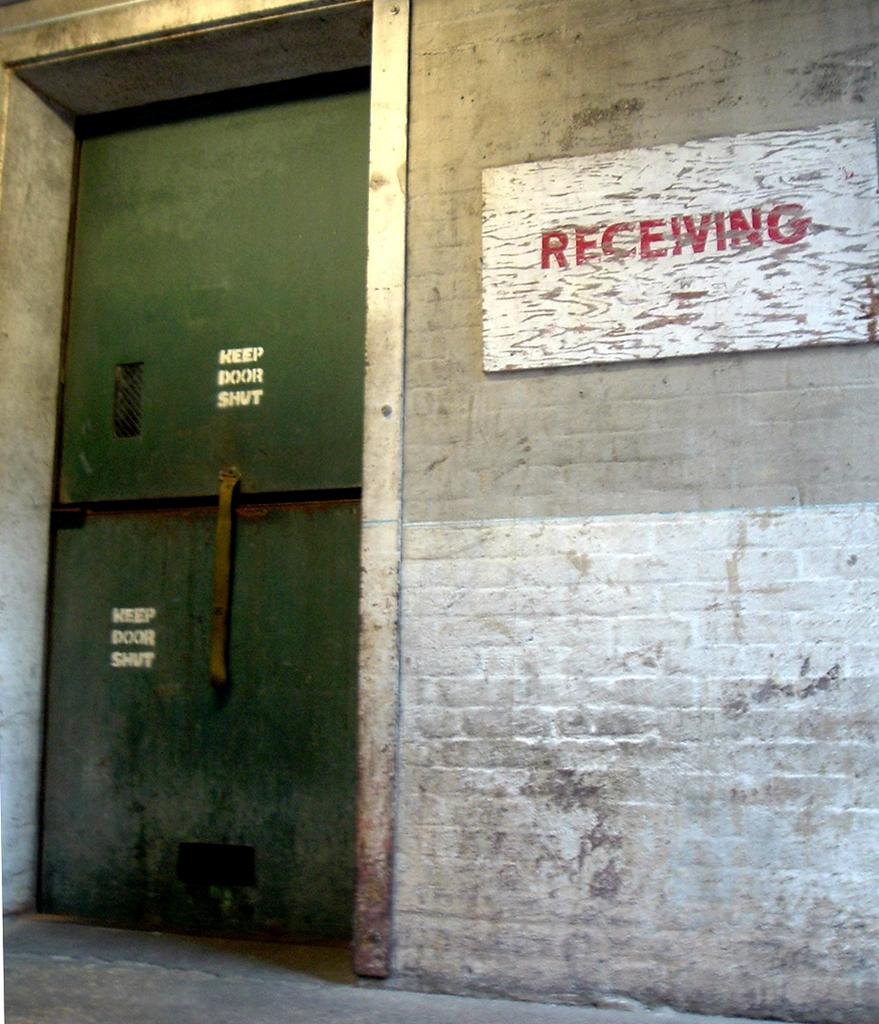What is located on the left side of the image? There is a door on the left side of the image. What can be seen on the right side of the image? There is a board with text attached to the wall on the right side of the image. Can you see an aunt playing a drum in the image? There is no drum or aunt present in the image. What type of rat is hiding behind the door in the image? There is no rat present in the image; it only features a door and a board with text on the wall. 